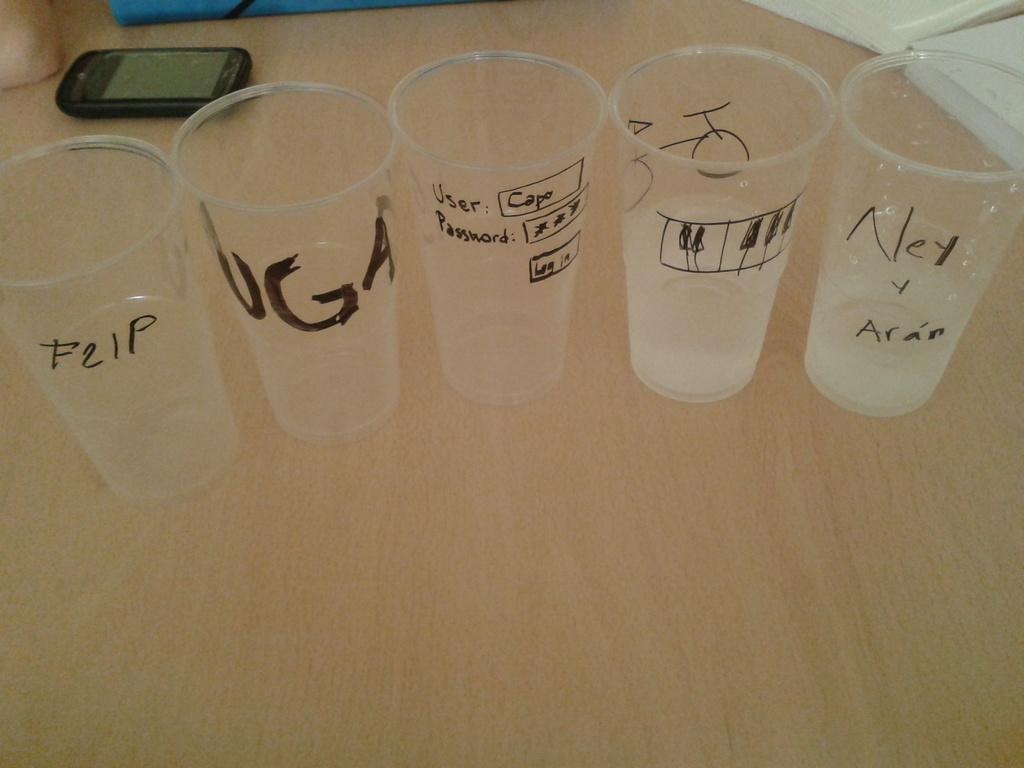<image>
Offer a succinct explanation of the picture presented. A cellphone sits behind 5 cups, the first one with the word F21P on it. 